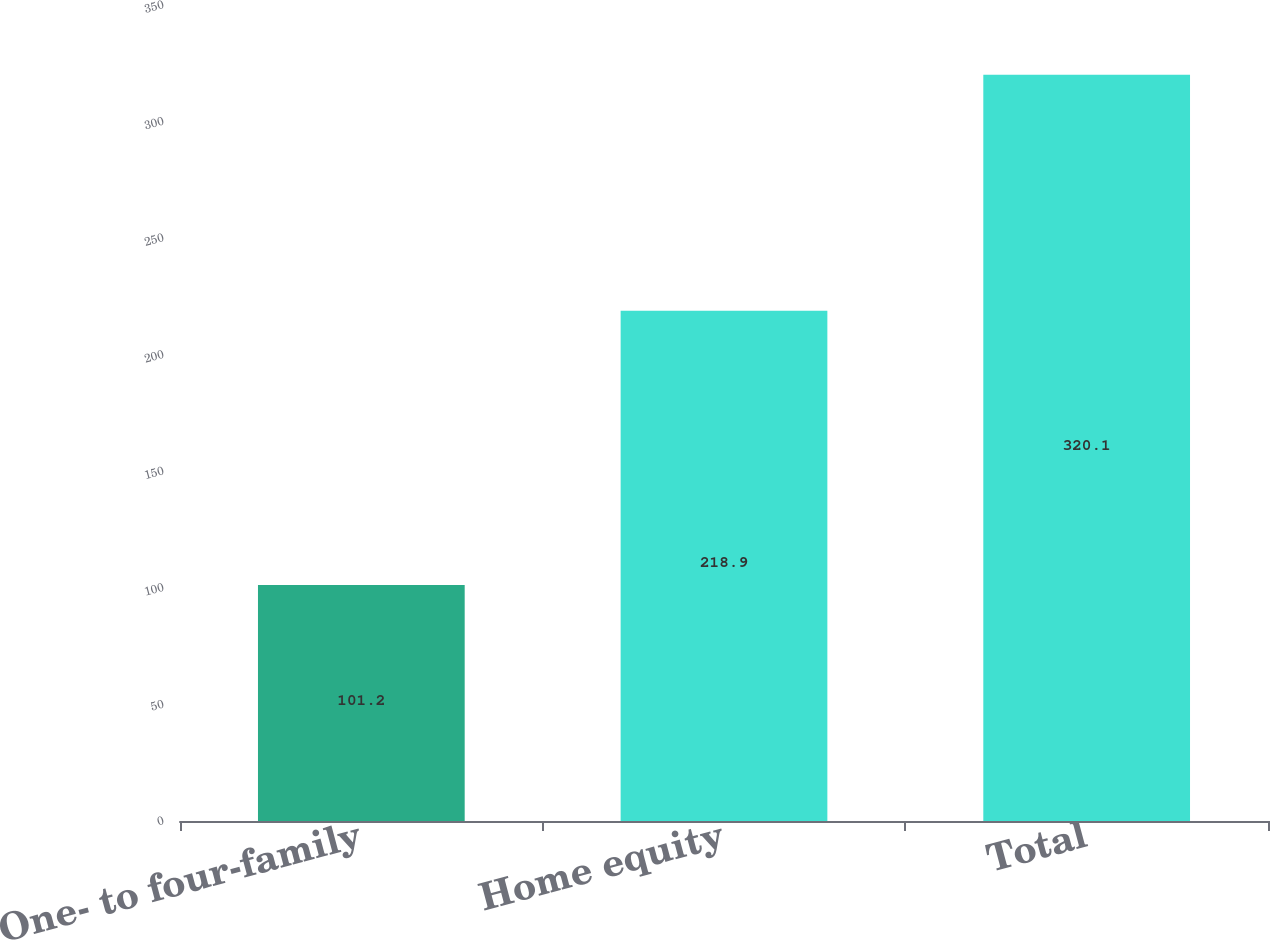<chart> <loc_0><loc_0><loc_500><loc_500><bar_chart><fcel>One- to four-family<fcel>Home equity<fcel>Total<nl><fcel>101.2<fcel>218.9<fcel>320.1<nl></chart> 